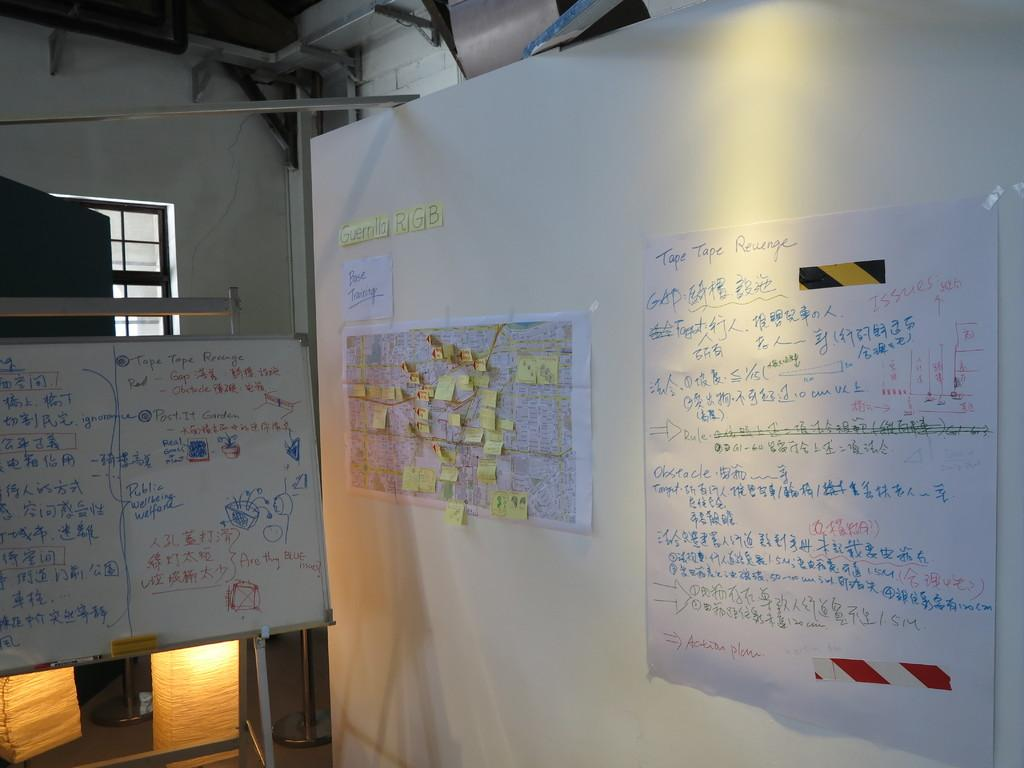<image>
Describe the image concisely. A notice board covered in post-its with the words guerilla RGB basic training posted above it, hangs between two larger boards covered in Chinese writing. 